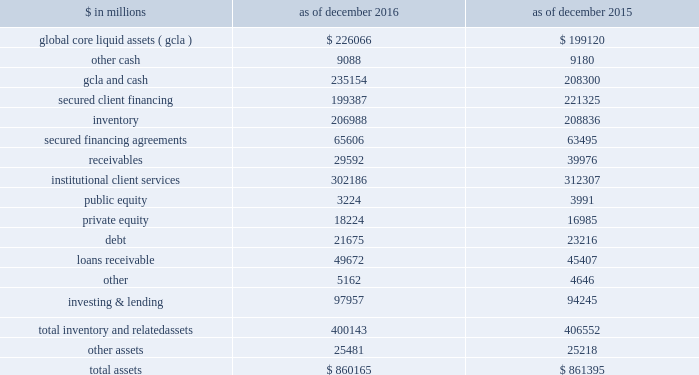The goldman sachs group , inc .
And subsidiaries management 2019s discussion and analysis scenario analyses .
We conduct various scenario analyses including as part of the comprehensive capital analysis and review ( ccar ) and dodd-frank act stress tests ( dfast ) , as well as our resolution and recovery planning .
See 201cequity capital management and regulatory capital 2014 equity capital management 201d below for further information about these scenario analyses .
These scenarios cover short-term and long-term time horizons using various macroeconomic and firm-specific assumptions , based on a range of economic scenarios .
We use these analyses to assist us in developing our longer-term balance sheet management strategy , including the level and composition of assets , funding and equity capital .
Additionally , these analyses help us develop approaches for maintaining appropriate funding , liquidity and capital across a variety of situations , including a severely stressed environment .
Balance sheet allocation in addition to preparing our consolidated statements of financial condition in accordance with u.s .
Gaap , we prepare a balance sheet that generally allocates assets to our businesses , which is a non-gaap presentation and may not be comparable to similar non-gaap presentations used by other companies .
We believe that presenting our assets on this basis is meaningful because it is consistent with the way management views and manages risks associated with our assets and better enables investors to assess the liquidity of our assets .
The table below presents our balance sheet allocation. .
The following is a description of the captions in the table above : 2030 global core liquid assets and cash .
We maintain liquidity to meet a broad range of potential cash outflows and collateral needs in a stressed environment .
See 201cliquidity risk management 201d below for details on the composition and sizing of our 201cglobal core liquid assets 201d ( gcla ) .
In addition to our gcla , we maintain other unrestricted operating cash balances , primarily for use in specific currencies , entities , or jurisdictions where we do not have immediate access to parent company liquidity .
2030 secured client financing .
We provide collateralized financing for client positions , including margin loans secured by client collateral , securities borrowed , and resale agreements primarily collateralized by government obligations .
We segregate cash and securities for regulatory and other purposes related to client activity .
Securities are segregated from our own inventory as well as from collateral obtained through securities borrowed or resale agreements .
Our secured client financing arrangements , which are generally short-term , are accounted for at fair value or at amounts that approximate fair value , and include daily margin requirements to mitigate counterparty credit risk .
2030 institutional client services .
In institutional client services , we maintain inventory positions to facilitate market making in fixed income , equity , currency and commodity products .
Additionally , as part of market- making activities , we enter into resale or securities borrowing arrangements to obtain securities or use our own inventory to cover transactions in which we or our clients have sold securities that have not yet been purchased .
The receivables in institutional client services primarily relate to securities transactions .
2030 investing & lending .
In investing & lending , we make investments and originate loans to provide financing to clients .
These investments and loans are typically longer- term in nature .
We make investments , directly and indirectly through funds that we manage , in debt securities , loans , public and private equity securities , infrastructure , real estate entities and other investments .
We also make unsecured loans to individuals through our online platform .
Debt includes $ 14.23 billion and $ 17.29 billion as of december 2016 and december 2015 , respectively , of direct loans primarily extended to corporate and private wealth management clients that are accounted for at fair value .
Loans receivable is comprised of loans held for investment that are accounted for at amortized cost net of allowance for loan losses .
See note 9 to the consolidated financial statements for further information about loans receivable .
Goldman sachs 2016 form 10-k 67 .
What is the debt-to-total asset ratio in 2016? 
Computations: (21675 / 860165)
Answer: 0.0252. 